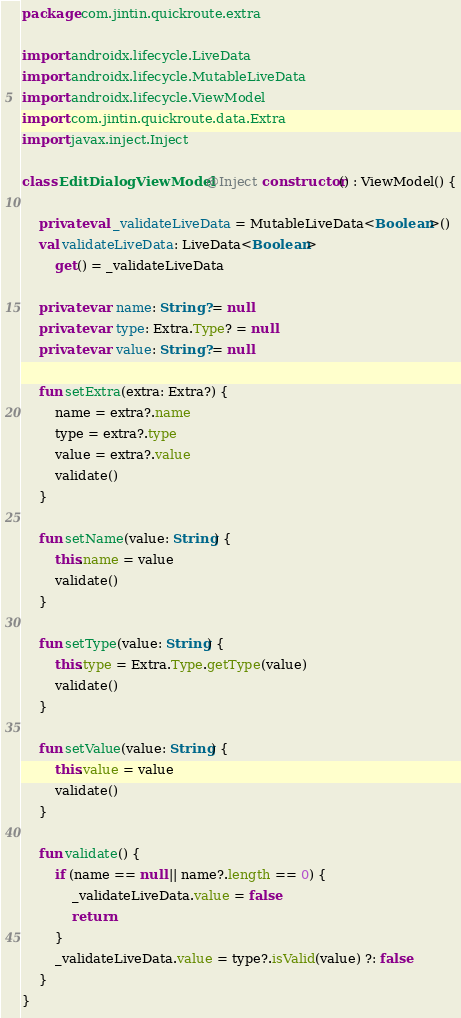Convert code to text. <code><loc_0><loc_0><loc_500><loc_500><_Kotlin_>package com.jintin.quickroute.extra

import androidx.lifecycle.LiveData
import androidx.lifecycle.MutableLiveData
import androidx.lifecycle.ViewModel
import com.jintin.quickroute.data.Extra
import javax.inject.Inject

class EditDialogViewModel @Inject constructor() : ViewModel() {

    private val _validateLiveData = MutableLiveData<Boolean>()
    val validateLiveData: LiveData<Boolean>
        get() = _validateLiveData

    private var name: String? = null
    private var type: Extra.Type? = null
    private var value: String? = null

    fun setExtra(extra: Extra?) {
        name = extra?.name
        type = extra?.type
        value = extra?.value
        validate()
    }

    fun setName(value: String) {
        this.name = value
        validate()
    }

    fun setType(value: String) {
        this.type = Extra.Type.getType(value)
        validate()
    }

    fun setValue(value: String) {
        this.value = value
        validate()
    }

    fun validate() {
        if (name == null || name?.length == 0) {
            _validateLiveData.value = false
            return
        }
        _validateLiveData.value = type?.isValid(value) ?: false
    }
}</code> 